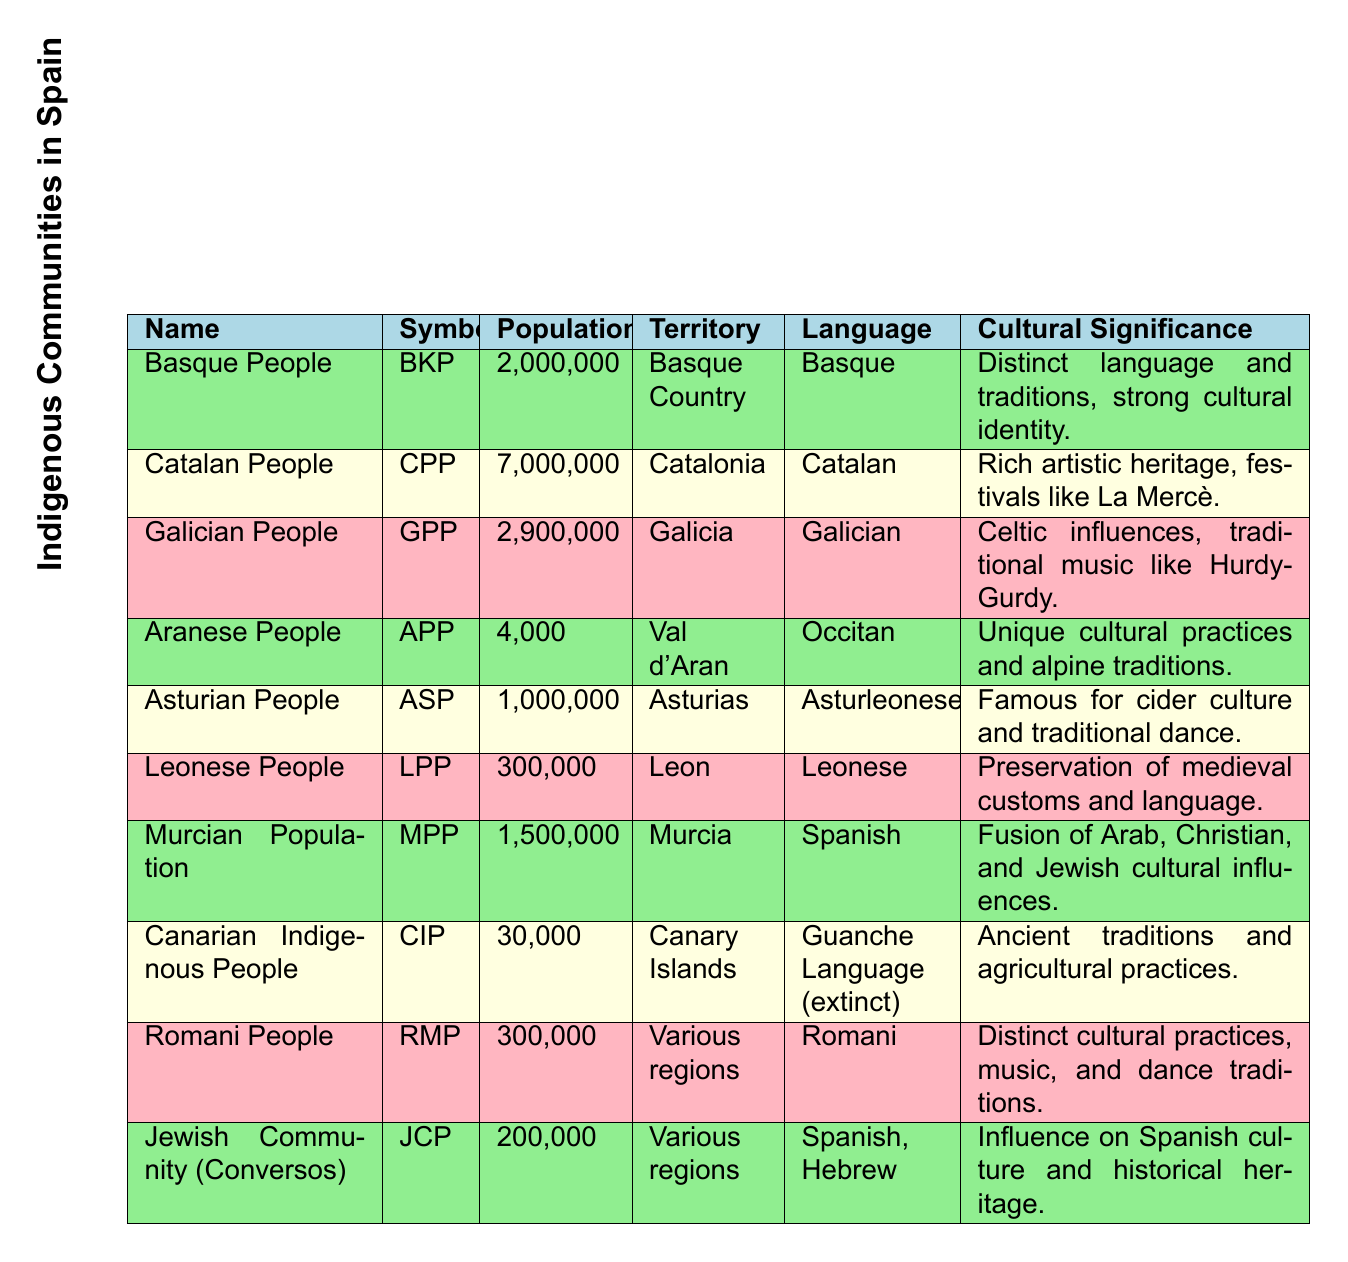What is the population of the Catalan People? The Catalan People are listed in the table with a population of 7,000,000, as indicated in the "Population" column.
Answer: 7,000,000 Which indigenous group has the smallest population? The Aranese People are noted in the table with a population of 4,000, which is the smallest figure compared to the other populations listed.
Answer: 4,000 What is the total population of the Basque People and Asturian People combined? The Basque People have a population of 2,000,000, and the Asturian People have a population of 1,000,000. Adding these together gives 2,000,000 + 1,000,000 = 3,000,000.
Answer: 3,000,000 Is the language of the Canarian Indigenous People still spoken today? The table states that the Guanche Language, which is associated with the Canarian Indigenous People, is marked as "extinct," indicating it is no longer spoken.
Answer: No Which community has a cultural significance related to cider culture? The Asturian People have a cultural significance that is famous for cider culture as described in the "Cultural Significance" column.
Answer: Asturian People What is the average population of the indigenous groups listed in the table? The total population of all listed groups is calculated by adding each group's population: 2,000,000 (Basque) + 7,000,000 (Catalan) + 2,900,000 (Galician) + 4,000 (Aranese) + 1,000,000 (Asturian) + 300,000 (Leonese) + 1,500,000 (Murcian) + 30,000 (Canarian) + 300,000 (Romani) + 200,000 (Jewish) = 15,337,000. There are 10 groups, so the average is 15,337,000 / 10 = 1,533,700.
Answer: 1,533,700 Which community is associated with the preservation of medieval customs and language? The Leonese People are noted for their preservation of medieval customs and language in the "Cultural Significance" column.
Answer: Leonese People How many more people belong to the Galician community than the Aranese community? The Galician People have a population of 2,900,000, while the Aranese People have a population of 4,000. The difference is 2,900,000 - 4,000 = 2,896,000.
Answer: 2,896,000 Is the combined population of the Jewish Community (Conversos) and the Murcian Population greater than that of the Basque People? The Jewish Community has a population of 200,000 and the Murcian Population has 1,500,000. The total is 200,000 + 1,500,000 = 1,700,000, which is less than the Basque People's population of 2,000,000.
Answer: No 